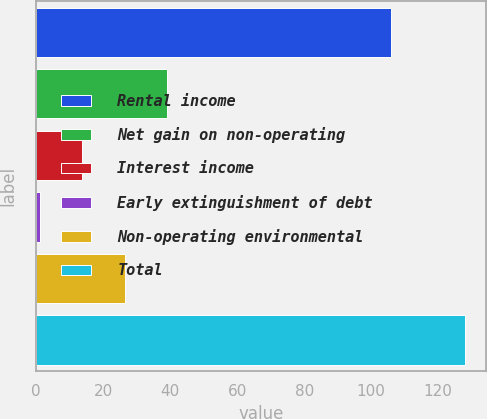<chart> <loc_0><loc_0><loc_500><loc_500><bar_chart><fcel>Rental income<fcel>Net gain on non-operating<fcel>Interest income<fcel>Early extinguishment of debt<fcel>Non-operating environmental<fcel>Total<nl><fcel>106<fcel>39.1<fcel>13.7<fcel>1<fcel>26.4<fcel>128<nl></chart> 